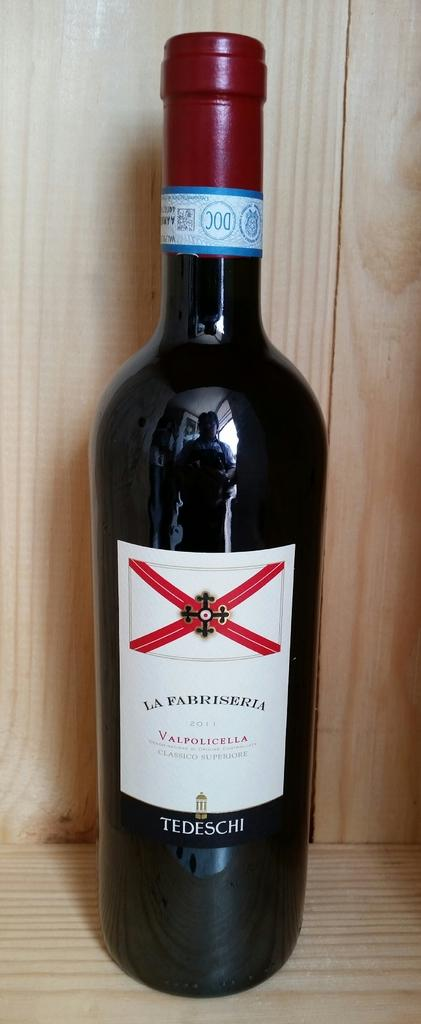<image>
Summarize the visual content of the image. A black bottle of wine with the label La Fabriseria. 